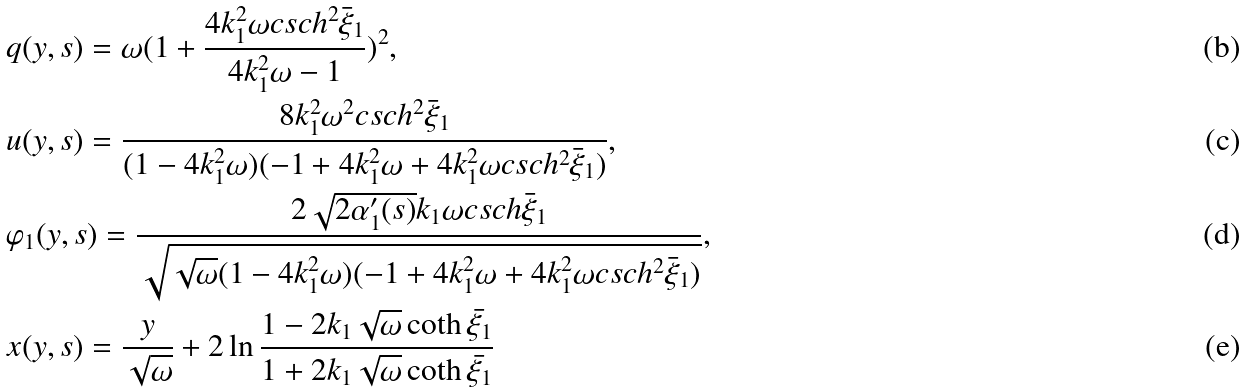<formula> <loc_0><loc_0><loc_500><loc_500>& q ( y , s ) = \omega ( 1 + \frac { 4 k _ { 1 } ^ { 2 } \omega c s c h ^ { 2 } \bar { \xi } _ { 1 } } { 4 k _ { 1 } ^ { 2 } \omega - 1 } ) ^ { 2 } , \\ & u ( y , s ) = \frac { 8 k _ { 1 } ^ { 2 } \omega ^ { 2 } c s c h ^ { 2 } \bar { \xi } _ { 1 } } { ( 1 - 4 k _ { 1 } ^ { 2 } \omega ) ( - 1 + 4 k _ { 1 } ^ { 2 } \omega + 4 k _ { 1 } ^ { 2 } \omega c s c h ^ { 2 } \bar { \xi } _ { 1 } ) } , \\ & \varphi _ { 1 } ( y , s ) = \frac { 2 \sqrt { 2 \alpha _ { 1 } ^ { \prime } ( s ) } k _ { 1 } \omega c s c h \bar { \xi } _ { 1 } } { \sqrt { \sqrt { \omega } ( 1 - 4 k _ { 1 } ^ { 2 } \omega ) ( - 1 + 4 k _ { 1 } ^ { 2 } \omega + 4 k _ { 1 } ^ { 2 } \omega c s c h ^ { 2 } \bar { \xi } _ { 1 } ) } } , \\ & x ( y , s ) = \frac { y } { \sqrt { \omega } } + 2 \ln \frac { 1 - 2 k _ { 1 } \sqrt { \omega } \coth \bar { \xi _ { 1 } } } { 1 + 2 k _ { 1 } \sqrt { \omega } \coth \bar { \xi _ { 1 } } }</formula> 